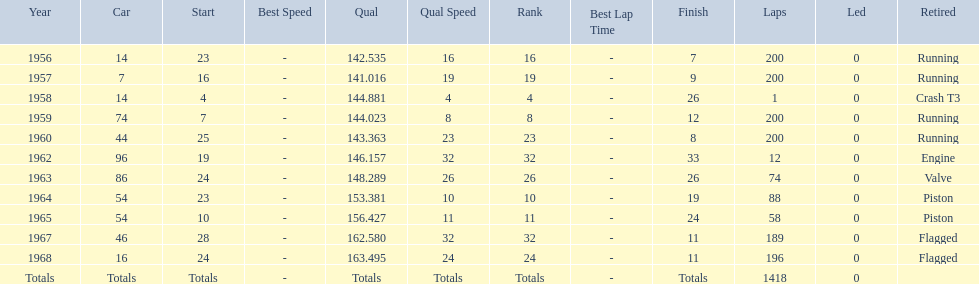Would you be able to parse every entry in this table? {'header': ['Year', 'Car', 'Start', 'Best Speed', 'Qual', 'Qual Speed', 'Rank', 'Best Lap Time', 'Finish', 'Laps', 'Led', 'Retired'], 'rows': [['1956', '14', '23', '-', '142.535', '16', '16', '-', '7', '200', '0', 'Running'], ['1957', '7', '16', '-', '141.016', '19', '19', '-', '9', '200', '0', 'Running'], ['1958', '14', '4', '-', '144.881', '4', '4', '-', '26', '1', '0', 'Crash T3'], ['1959', '74', '7', '-', '144.023', '8', '8', '-', '12', '200', '0', 'Running'], ['1960', '44', '25', '-', '143.363', '23', '23', '-', '8', '200', '0', 'Running'], ['1962', '96', '19', '-', '146.157', '32', '32', '-', '33', '12', '0', 'Engine'], ['1963', '86', '24', '-', '148.289', '26', '26', '-', '26', '74', '0', 'Valve'], ['1964', '54', '23', '-', '153.381', '10', '10', '-', '19', '88', '0', 'Piston'], ['1965', '54', '10', '-', '156.427', '11', '11', '-', '24', '58', '0', 'Piston'], ['1967', '46', '28', '-', '162.580', '32', '32', '-', '11', '189', '0', 'Flagged'], ['1968', '16', '24', '-', '163.495', '24', '24', '-', '11', '196', '0', 'Flagged'], ['Totals', 'Totals', 'Totals', '-', 'Totals', 'Totals', 'Totals', '-', 'Totals', '1418', '0', '']]} What is the larger laps between 1963 or 1968 1968. 